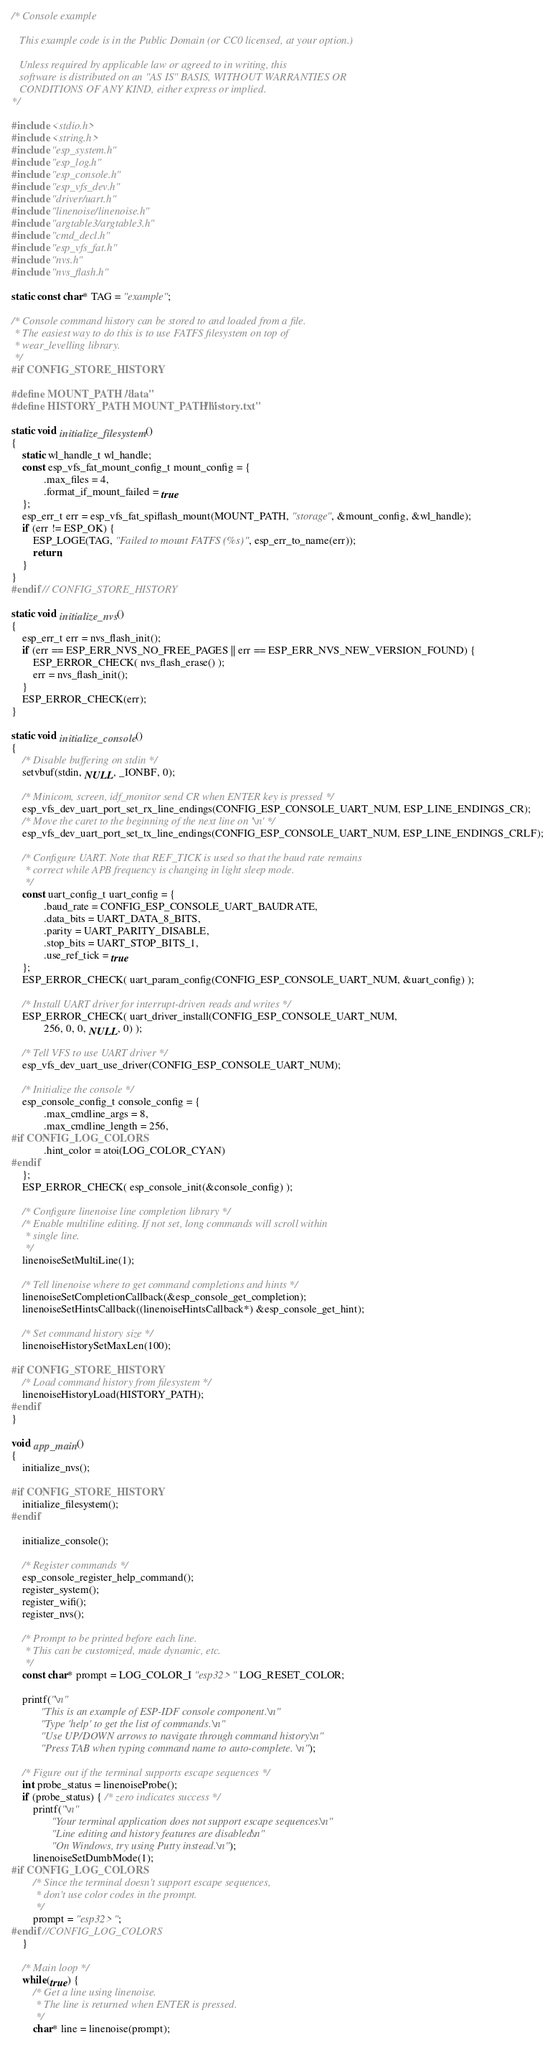Convert code to text. <code><loc_0><loc_0><loc_500><loc_500><_C_>/* Console example

   This example code is in the Public Domain (or CC0 licensed, at your option.)

   Unless required by applicable law or agreed to in writing, this
   software is distributed on an "AS IS" BASIS, WITHOUT WARRANTIES OR
   CONDITIONS OF ANY KIND, either express or implied.
*/

#include <stdio.h>
#include <string.h>
#include "esp_system.h"
#include "esp_log.h"
#include "esp_console.h"
#include "esp_vfs_dev.h"
#include "driver/uart.h"
#include "linenoise/linenoise.h"
#include "argtable3/argtable3.h"
#include "cmd_decl.h"
#include "esp_vfs_fat.h"
#include "nvs.h"
#include "nvs_flash.h"

static const char* TAG = "example";

/* Console command history can be stored to and loaded from a file.
 * The easiest way to do this is to use FATFS filesystem on top of
 * wear_levelling library.
 */
#if CONFIG_STORE_HISTORY

#define MOUNT_PATH "/data"
#define HISTORY_PATH MOUNT_PATH "/history.txt"

static void initialize_filesystem()
{
    static wl_handle_t wl_handle;
    const esp_vfs_fat_mount_config_t mount_config = {
            .max_files = 4,
            .format_if_mount_failed = true
    };
    esp_err_t err = esp_vfs_fat_spiflash_mount(MOUNT_PATH, "storage", &mount_config, &wl_handle);
    if (err != ESP_OK) {
        ESP_LOGE(TAG, "Failed to mount FATFS (%s)", esp_err_to_name(err));
        return;
    }
}
#endif // CONFIG_STORE_HISTORY

static void initialize_nvs()
{
    esp_err_t err = nvs_flash_init();
    if (err == ESP_ERR_NVS_NO_FREE_PAGES || err == ESP_ERR_NVS_NEW_VERSION_FOUND) {
        ESP_ERROR_CHECK( nvs_flash_erase() );
        err = nvs_flash_init();
    }
    ESP_ERROR_CHECK(err);
}

static void initialize_console()
{
    /* Disable buffering on stdin */
    setvbuf(stdin, NULL, _IONBF, 0);

    /* Minicom, screen, idf_monitor send CR when ENTER key is pressed */
    esp_vfs_dev_uart_port_set_rx_line_endings(CONFIG_ESP_CONSOLE_UART_NUM, ESP_LINE_ENDINGS_CR);
    /* Move the caret to the beginning of the next line on '\n' */
    esp_vfs_dev_uart_port_set_tx_line_endings(CONFIG_ESP_CONSOLE_UART_NUM, ESP_LINE_ENDINGS_CRLF);

    /* Configure UART. Note that REF_TICK is used so that the baud rate remains
     * correct while APB frequency is changing in light sleep mode.
     */
    const uart_config_t uart_config = {
            .baud_rate = CONFIG_ESP_CONSOLE_UART_BAUDRATE,
            .data_bits = UART_DATA_8_BITS,
            .parity = UART_PARITY_DISABLE,
            .stop_bits = UART_STOP_BITS_1,
            .use_ref_tick = true
    };
    ESP_ERROR_CHECK( uart_param_config(CONFIG_ESP_CONSOLE_UART_NUM, &uart_config) );

    /* Install UART driver for interrupt-driven reads and writes */
    ESP_ERROR_CHECK( uart_driver_install(CONFIG_ESP_CONSOLE_UART_NUM,
            256, 0, 0, NULL, 0) );

    /* Tell VFS to use UART driver */
    esp_vfs_dev_uart_use_driver(CONFIG_ESP_CONSOLE_UART_NUM);

    /* Initialize the console */
    esp_console_config_t console_config = {
            .max_cmdline_args = 8,
            .max_cmdline_length = 256,
#if CONFIG_LOG_COLORS
            .hint_color = atoi(LOG_COLOR_CYAN)
#endif
    };
    ESP_ERROR_CHECK( esp_console_init(&console_config) );

    /* Configure linenoise line completion library */
    /* Enable multiline editing. If not set, long commands will scroll within
     * single line.
     */
    linenoiseSetMultiLine(1);

    /* Tell linenoise where to get command completions and hints */
    linenoiseSetCompletionCallback(&esp_console_get_completion);
    linenoiseSetHintsCallback((linenoiseHintsCallback*) &esp_console_get_hint);

    /* Set command history size */
    linenoiseHistorySetMaxLen(100);

#if CONFIG_STORE_HISTORY
    /* Load command history from filesystem */
    linenoiseHistoryLoad(HISTORY_PATH);
#endif
}

void app_main()
{
    initialize_nvs();

#if CONFIG_STORE_HISTORY
    initialize_filesystem();
#endif

    initialize_console();

    /* Register commands */
    esp_console_register_help_command();
    register_system();
    register_wifi();
    register_nvs();

    /* Prompt to be printed before each line.
     * This can be customized, made dynamic, etc.
     */
    const char* prompt = LOG_COLOR_I "esp32> " LOG_RESET_COLOR;

    printf("\n"
           "This is an example of ESP-IDF console component.\n"
           "Type 'help' to get the list of commands.\n"
           "Use UP/DOWN arrows to navigate through command history.\n"
           "Press TAB when typing command name to auto-complete.\n");

    /* Figure out if the terminal supports escape sequences */
    int probe_status = linenoiseProbe();
    if (probe_status) { /* zero indicates success */
        printf("\n"
               "Your terminal application does not support escape sequences.\n"
               "Line editing and history features are disabled.\n"
               "On Windows, try using Putty instead.\n");
        linenoiseSetDumbMode(1);
#if CONFIG_LOG_COLORS
        /* Since the terminal doesn't support escape sequences,
         * don't use color codes in the prompt.
         */
        prompt = "esp32> ";
#endif //CONFIG_LOG_COLORS
    }

    /* Main loop */
    while(true) {
        /* Get a line using linenoise.
         * The line is returned when ENTER is pressed.
         */
        char* line = linenoise(prompt);</code> 